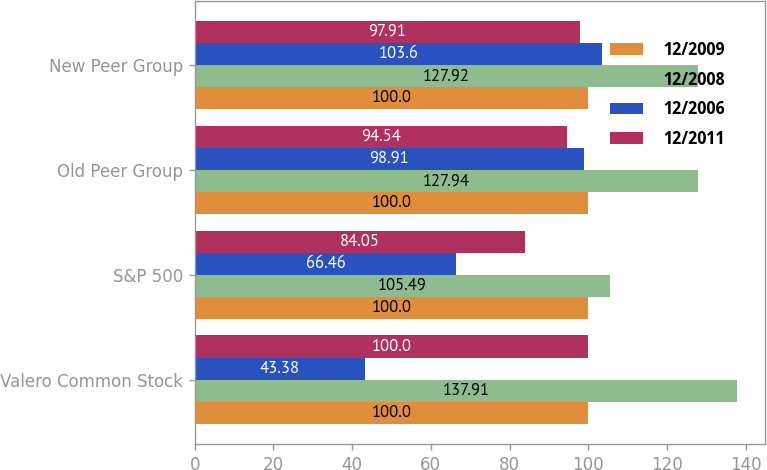<chart> <loc_0><loc_0><loc_500><loc_500><stacked_bar_chart><ecel><fcel>Valero Common Stock<fcel>S&P 500<fcel>Old Peer Group<fcel>New Peer Group<nl><fcel>12/2009<fcel>100<fcel>100<fcel>100<fcel>100<nl><fcel>12/2008<fcel>137.91<fcel>105.49<fcel>127.94<fcel>127.92<nl><fcel>12/2006<fcel>43.38<fcel>66.46<fcel>98.91<fcel>103.6<nl><fcel>12/2011<fcel>100<fcel>84.05<fcel>94.54<fcel>97.91<nl></chart> 